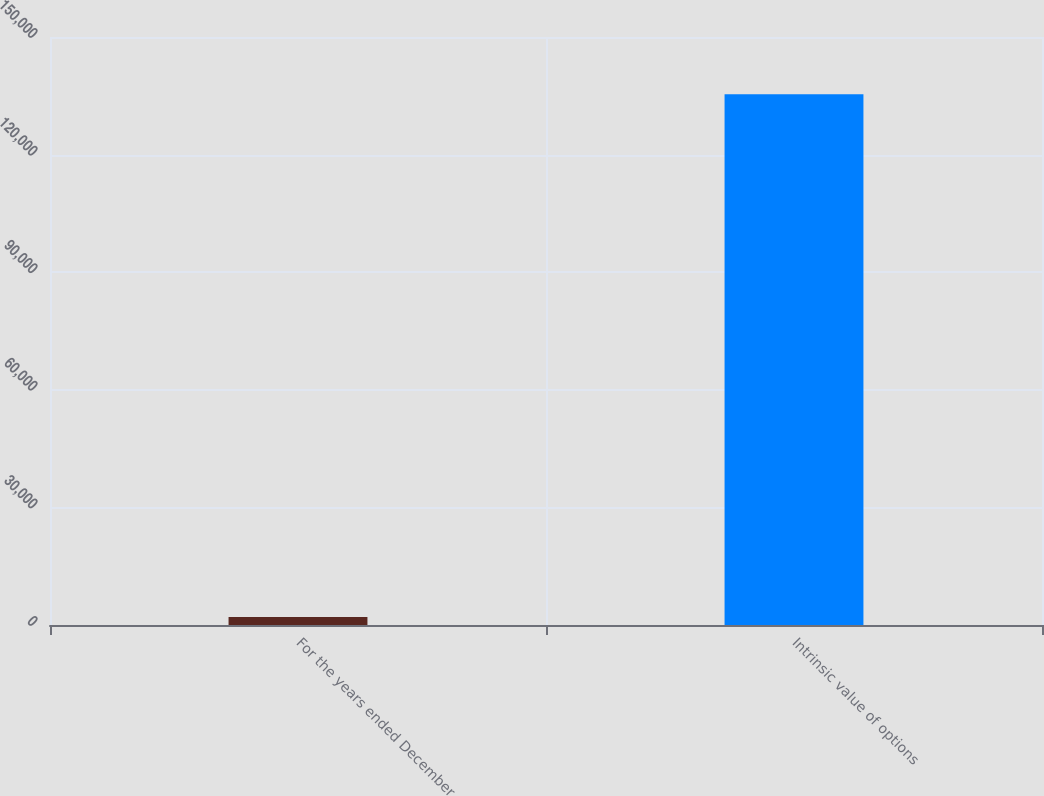<chart> <loc_0><loc_0><loc_500><loc_500><bar_chart><fcel>For the years ended December<fcel>Intrinsic value of options<nl><fcel>2013<fcel>135396<nl></chart> 